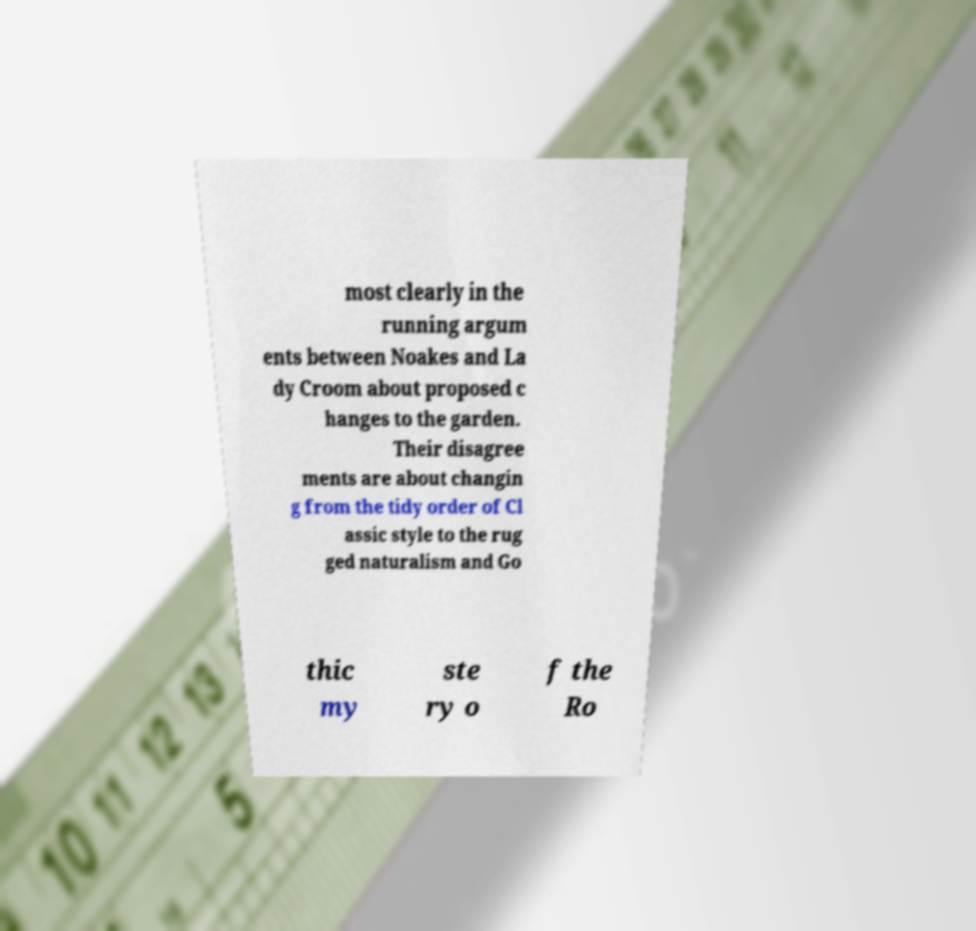There's text embedded in this image that I need extracted. Can you transcribe it verbatim? most clearly in the running argum ents between Noakes and La dy Croom about proposed c hanges to the garden. Their disagree ments are about changin g from the tidy order of Cl assic style to the rug ged naturalism and Go thic my ste ry o f the Ro 